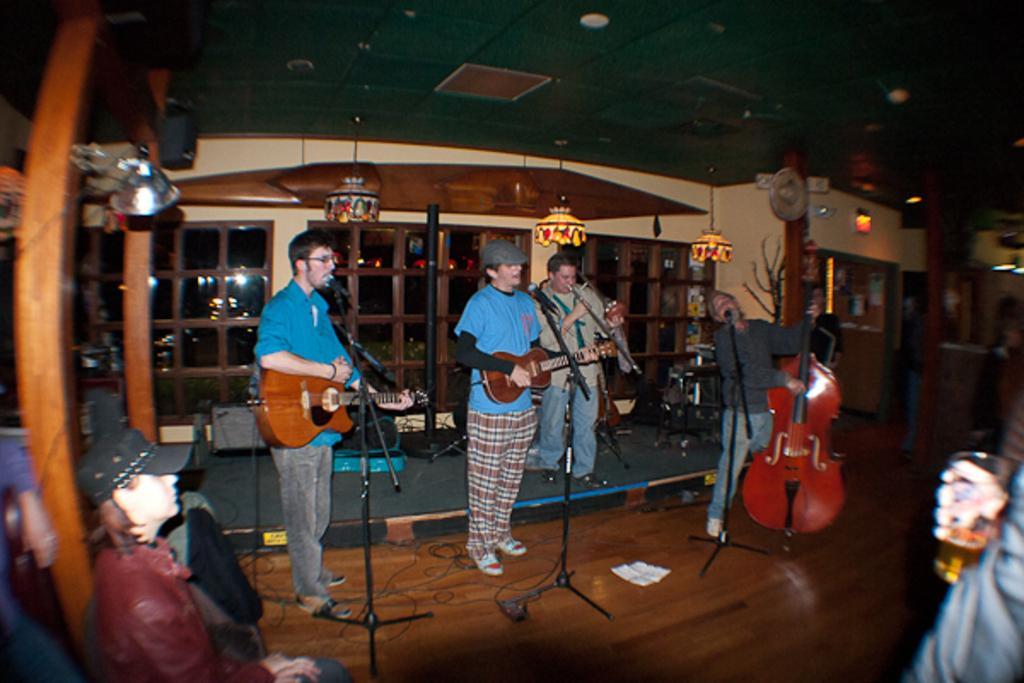Describe this image in one or two sentences. In this image the four people are playing the musical instrument and the person is holding a glass. 